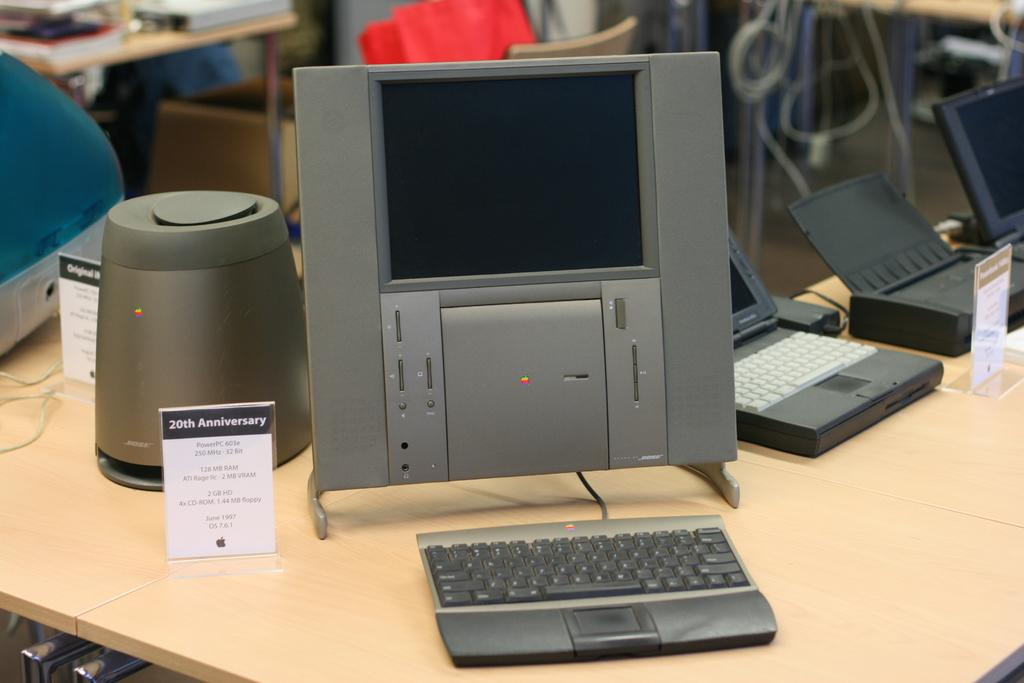Provide a one-sentence caption for the provided image. A small desktop PC on a table with a 20th Anniversary Bose speaker next to it. 